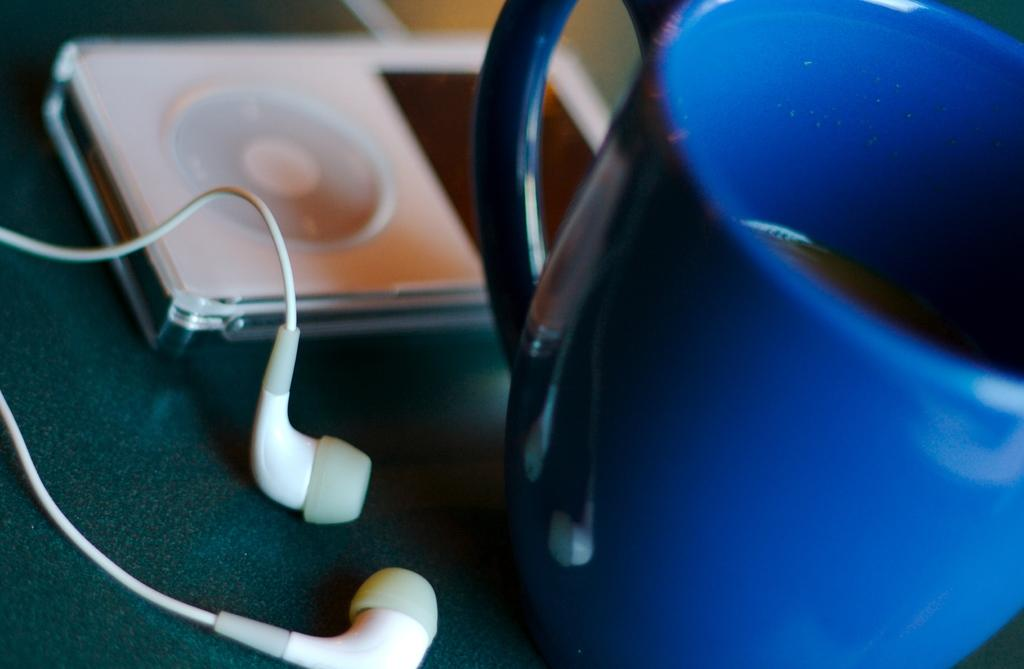What type of audio device is present in the image? There are earphones in the image. What device might the earphones be connected to? There is an iPod in the image, which the earphones might be connected to. What else can be seen in the image besides the audio devices? There is a cup in the image. What type of harmony is being played on the vest in the image? A: There is no vest or music being played in the image; it only features earphones, an iPod, and a cup. 